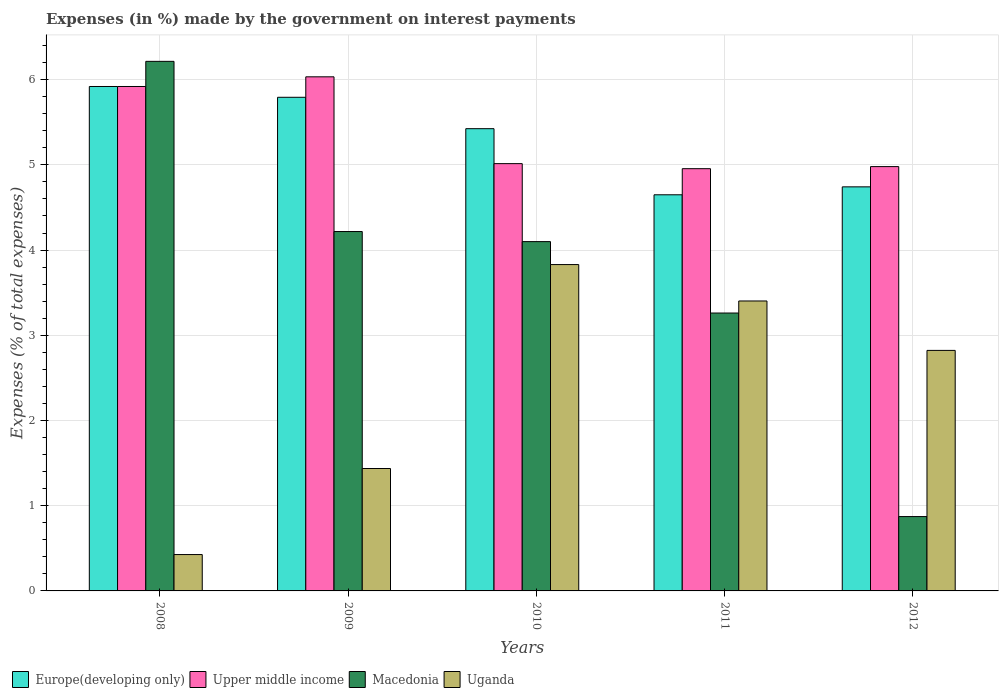How many different coloured bars are there?
Provide a short and direct response. 4. How many groups of bars are there?
Your answer should be compact. 5. Are the number of bars per tick equal to the number of legend labels?
Make the answer very short. Yes. Are the number of bars on each tick of the X-axis equal?
Make the answer very short. Yes. How many bars are there on the 3rd tick from the left?
Your answer should be compact. 4. How many bars are there on the 3rd tick from the right?
Keep it short and to the point. 4. What is the label of the 4th group of bars from the left?
Offer a terse response. 2011. What is the percentage of expenses made by the government on interest payments in Uganda in 2009?
Offer a very short reply. 1.44. Across all years, what is the maximum percentage of expenses made by the government on interest payments in Uganda?
Offer a very short reply. 3.83. Across all years, what is the minimum percentage of expenses made by the government on interest payments in Europe(developing only)?
Ensure brevity in your answer.  4.65. In which year was the percentage of expenses made by the government on interest payments in Europe(developing only) maximum?
Offer a terse response. 2008. In which year was the percentage of expenses made by the government on interest payments in Uganda minimum?
Your answer should be compact. 2008. What is the total percentage of expenses made by the government on interest payments in Macedonia in the graph?
Ensure brevity in your answer.  18.66. What is the difference between the percentage of expenses made by the government on interest payments in Upper middle income in 2010 and that in 2011?
Provide a succinct answer. 0.06. What is the difference between the percentage of expenses made by the government on interest payments in Upper middle income in 2008 and the percentage of expenses made by the government on interest payments in Uganda in 2009?
Your response must be concise. 4.48. What is the average percentage of expenses made by the government on interest payments in Uganda per year?
Keep it short and to the point. 2.38. In the year 2008, what is the difference between the percentage of expenses made by the government on interest payments in Macedonia and percentage of expenses made by the government on interest payments in Uganda?
Offer a terse response. 5.79. What is the ratio of the percentage of expenses made by the government on interest payments in Europe(developing only) in 2011 to that in 2012?
Provide a succinct answer. 0.98. Is the difference between the percentage of expenses made by the government on interest payments in Macedonia in 2010 and 2012 greater than the difference between the percentage of expenses made by the government on interest payments in Uganda in 2010 and 2012?
Your answer should be compact. Yes. What is the difference between the highest and the second highest percentage of expenses made by the government on interest payments in Europe(developing only)?
Make the answer very short. 0.13. What is the difference between the highest and the lowest percentage of expenses made by the government on interest payments in Europe(developing only)?
Provide a short and direct response. 1.27. What does the 4th bar from the left in 2011 represents?
Keep it short and to the point. Uganda. What does the 1st bar from the right in 2009 represents?
Provide a succinct answer. Uganda. Are all the bars in the graph horizontal?
Keep it short and to the point. No. What is the difference between two consecutive major ticks on the Y-axis?
Make the answer very short. 1. Are the values on the major ticks of Y-axis written in scientific E-notation?
Provide a succinct answer. No. Does the graph contain any zero values?
Provide a succinct answer. No. How many legend labels are there?
Ensure brevity in your answer.  4. What is the title of the graph?
Your answer should be compact. Expenses (in %) made by the government on interest payments. Does "Fragile and conflict affected situations" appear as one of the legend labels in the graph?
Your answer should be very brief. No. What is the label or title of the Y-axis?
Make the answer very short. Expenses (% of total expenses). What is the Expenses (% of total expenses) in Europe(developing only) in 2008?
Keep it short and to the point. 5.92. What is the Expenses (% of total expenses) of Upper middle income in 2008?
Provide a short and direct response. 5.92. What is the Expenses (% of total expenses) in Macedonia in 2008?
Offer a terse response. 6.21. What is the Expenses (% of total expenses) of Uganda in 2008?
Make the answer very short. 0.43. What is the Expenses (% of total expenses) of Europe(developing only) in 2009?
Give a very brief answer. 5.79. What is the Expenses (% of total expenses) in Upper middle income in 2009?
Provide a succinct answer. 6.03. What is the Expenses (% of total expenses) of Macedonia in 2009?
Provide a succinct answer. 4.22. What is the Expenses (% of total expenses) in Uganda in 2009?
Offer a very short reply. 1.44. What is the Expenses (% of total expenses) of Europe(developing only) in 2010?
Your answer should be compact. 5.42. What is the Expenses (% of total expenses) of Upper middle income in 2010?
Give a very brief answer. 5.01. What is the Expenses (% of total expenses) of Macedonia in 2010?
Provide a succinct answer. 4.1. What is the Expenses (% of total expenses) in Uganda in 2010?
Make the answer very short. 3.83. What is the Expenses (% of total expenses) in Europe(developing only) in 2011?
Your answer should be very brief. 4.65. What is the Expenses (% of total expenses) of Upper middle income in 2011?
Keep it short and to the point. 4.96. What is the Expenses (% of total expenses) in Macedonia in 2011?
Ensure brevity in your answer.  3.26. What is the Expenses (% of total expenses) of Uganda in 2011?
Keep it short and to the point. 3.4. What is the Expenses (% of total expenses) of Europe(developing only) in 2012?
Your answer should be compact. 4.74. What is the Expenses (% of total expenses) of Upper middle income in 2012?
Offer a very short reply. 4.98. What is the Expenses (% of total expenses) of Macedonia in 2012?
Provide a succinct answer. 0.87. What is the Expenses (% of total expenses) in Uganda in 2012?
Provide a succinct answer. 2.82. Across all years, what is the maximum Expenses (% of total expenses) in Europe(developing only)?
Your answer should be compact. 5.92. Across all years, what is the maximum Expenses (% of total expenses) of Upper middle income?
Your response must be concise. 6.03. Across all years, what is the maximum Expenses (% of total expenses) of Macedonia?
Provide a short and direct response. 6.21. Across all years, what is the maximum Expenses (% of total expenses) in Uganda?
Provide a short and direct response. 3.83. Across all years, what is the minimum Expenses (% of total expenses) in Europe(developing only)?
Offer a terse response. 4.65. Across all years, what is the minimum Expenses (% of total expenses) of Upper middle income?
Your response must be concise. 4.96. Across all years, what is the minimum Expenses (% of total expenses) in Macedonia?
Offer a terse response. 0.87. Across all years, what is the minimum Expenses (% of total expenses) in Uganda?
Offer a terse response. 0.43. What is the total Expenses (% of total expenses) in Europe(developing only) in the graph?
Offer a very short reply. 26.53. What is the total Expenses (% of total expenses) in Upper middle income in the graph?
Your answer should be compact. 26.9. What is the total Expenses (% of total expenses) in Macedonia in the graph?
Provide a short and direct response. 18.66. What is the total Expenses (% of total expenses) of Uganda in the graph?
Give a very brief answer. 11.92. What is the difference between the Expenses (% of total expenses) of Europe(developing only) in 2008 and that in 2009?
Give a very brief answer. 0.13. What is the difference between the Expenses (% of total expenses) of Upper middle income in 2008 and that in 2009?
Offer a very short reply. -0.11. What is the difference between the Expenses (% of total expenses) in Macedonia in 2008 and that in 2009?
Provide a succinct answer. 2. What is the difference between the Expenses (% of total expenses) in Uganda in 2008 and that in 2009?
Your answer should be compact. -1.01. What is the difference between the Expenses (% of total expenses) of Europe(developing only) in 2008 and that in 2010?
Give a very brief answer. 0.5. What is the difference between the Expenses (% of total expenses) of Upper middle income in 2008 and that in 2010?
Keep it short and to the point. 0.91. What is the difference between the Expenses (% of total expenses) of Macedonia in 2008 and that in 2010?
Make the answer very short. 2.12. What is the difference between the Expenses (% of total expenses) in Uganda in 2008 and that in 2010?
Your answer should be very brief. -3.4. What is the difference between the Expenses (% of total expenses) of Europe(developing only) in 2008 and that in 2011?
Ensure brevity in your answer.  1.27. What is the difference between the Expenses (% of total expenses) in Upper middle income in 2008 and that in 2011?
Your answer should be very brief. 0.96. What is the difference between the Expenses (% of total expenses) in Macedonia in 2008 and that in 2011?
Offer a very short reply. 2.95. What is the difference between the Expenses (% of total expenses) of Uganda in 2008 and that in 2011?
Make the answer very short. -2.98. What is the difference between the Expenses (% of total expenses) of Europe(developing only) in 2008 and that in 2012?
Your response must be concise. 1.18. What is the difference between the Expenses (% of total expenses) in Upper middle income in 2008 and that in 2012?
Ensure brevity in your answer.  0.94. What is the difference between the Expenses (% of total expenses) in Macedonia in 2008 and that in 2012?
Offer a terse response. 5.34. What is the difference between the Expenses (% of total expenses) of Uganda in 2008 and that in 2012?
Offer a terse response. -2.4. What is the difference between the Expenses (% of total expenses) in Europe(developing only) in 2009 and that in 2010?
Your answer should be compact. 0.37. What is the difference between the Expenses (% of total expenses) of Upper middle income in 2009 and that in 2010?
Keep it short and to the point. 1.02. What is the difference between the Expenses (% of total expenses) of Macedonia in 2009 and that in 2010?
Make the answer very short. 0.12. What is the difference between the Expenses (% of total expenses) of Uganda in 2009 and that in 2010?
Keep it short and to the point. -2.39. What is the difference between the Expenses (% of total expenses) of Europe(developing only) in 2009 and that in 2011?
Your answer should be very brief. 1.14. What is the difference between the Expenses (% of total expenses) in Upper middle income in 2009 and that in 2011?
Make the answer very short. 1.08. What is the difference between the Expenses (% of total expenses) of Macedonia in 2009 and that in 2011?
Provide a short and direct response. 0.96. What is the difference between the Expenses (% of total expenses) of Uganda in 2009 and that in 2011?
Ensure brevity in your answer.  -1.97. What is the difference between the Expenses (% of total expenses) in Europe(developing only) in 2009 and that in 2012?
Give a very brief answer. 1.05. What is the difference between the Expenses (% of total expenses) in Upper middle income in 2009 and that in 2012?
Provide a succinct answer. 1.05. What is the difference between the Expenses (% of total expenses) of Macedonia in 2009 and that in 2012?
Your answer should be compact. 3.34. What is the difference between the Expenses (% of total expenses) of Uganda in 2009 and that in 2012?
Provide a succinct answer. -1.39. What is the difference between the Expenses (% of total expenses) in Europe(developing only) in 2010 and that in 2011?
Your answer should be very brief. 0.78. What is the difference between the Expenses (% of total expenses) in Upper middle income in 2010 and that in 2011?
Provide a succinct answer. 0.06. What is the difference between the Expenses (% of total expenses) of Macedonia in 2010 and that in 2011?
Provide a succinct answer. 0.84. What is the difference between the Expenses (% of total expenses) of Uganda in 2010 and that in 2011?
Provide a succinct answer. 0.43. What is the difference between the Expenses (% of total expenses) in Europe(developing only) in 2010 and that in 2012?
Your answer should be very brief. 0.68. What is the difference between the Expenses (% of total expenses) in Upper middle income in 2010 and that in 2012?
Offer a terse response. 0.03. What is the difference between the Expenses (% of total expenses) in Macedonia in 2010 and that in 2012?
Keep it short and to the point. 3.23. What is the difference between the Expenses (% of total expenses) of Uganda in 2010 and that in 2012?
Provide a succinct answer. 1.01. What is the difference between the Expenses (% of total expenses) in Europe(developing only) in 2011 and that in 2012?
Make the answer very short. -0.09. What is the difference between the Expenses (% of total expenses) in Upper middle income in 2011 and that in 2012?
Provide a succinct answer. -0.02. What is the difference between the Expenses (% of total expenses) in Macedonia in 2011 and that in 2012?
Your answer should be compact. 2.39. What is the difference between the Expenses (% of total expenses) of Uganda in 2011 and that in 2012?
Give a very brief answer. 0.58. What is the difference between the Expenses (% of total expenses) of Europe(developing only) in 2008 and the Expenses (% of total expenses) of Upper middle income in 2009?
Your answer should be very brief. -0.11. What is the difference between the Expenses (% of total expenses) of Europe(developing only) in 2008 and the Expenses (% of total expenses) of Macedonia in 2009?
Your answer should be compact. 1.7. What is the difference between the Expenses (% of total expenses) of Europe(developing only) in 2008 and the Expenses (% of total expenses) of Uganda in 2009?
Provide a succinct answer. 4.48. What is the difference between the Expenses (% of total expenses) in Upper middle income in 2008 and the Expenses (% of total expenses) in Macedonia in 2009?
Ensure brevity in your answer.  1.7. What is the difference between the Expenses (% of total expenses) in Upper middle income in 2008 and the Expenses (% of total expenses) in Uganda in 2009?
Provide a succinct answer. 4.48. What is the difference between the Expenses (% of total expenses) of Macedonia in 2008 and the Expenses (% of total expenses) of Uganda in 2009?
Give a very brief answer. 4.78. What is the difference between the Expenses (% of total expenses) of Europe(developing only) in 2008 and the Expenses (% of total expenses) of Upper middle income in 2010?
Your answer should be very brief. 0.91. What is the difference between the Expenses (% of total expenses) in Europe(developing only) in 2008 and the Expenses (% of total expenses) in Macedonia in 2010?
Your answer should be compact. 1.82. What is the difference between the Expenses (% of total expenses) of Europe(developing only) in 2008 and the Expenses (% of total expenses) of Uganda in 2010?
Make the answer very short. 2.09. What is the difference between the Expenses (% of total expenses) in Upper middle income in 2008 and the Expenses (% of total expenses) in Macedonia in 2010?
Provide a succinct answer. 1.82. What is the difference between the Expenses (% of total expenses) in Upper middle income in 2008 and the Expenses (% of total expenses) in Uganda in 2010?
Make the answer very short. 2.09. What is the difference between the Expenses (% of total expenses) of Macedonia in 2008 and the Expenses (% of total expenses) of Uganda in 2010?
Offer a very short reply. 2.38. What is the difference between the Expenses (% of total expenses) of Europe(developing only) in 2008 and the Expenses (% of total expenses) of Upper middle income in 2011?
Your answer should be very brief. 0.96. What is the difference between the Expenses (% of total expenses) in Europe(developing only) in 2008 and the Expenses (% of total expenses) in Macedonia in 2011?
Make the answer very short. 2.66. What is the difference between the Expenses (% of total expenses) of Europe(developing only) in 2008 and the Expenses (% of total expenses) of Uganda in 2011?
Offer a terse response. 2.52. What is the difference between the Expenses (% of total expenses) in Upper middle income in 2008 and the Expenses (% of total expenses) in Macedonia in 2011?
Give a very brief answer. 2.66. What is the difference between the Expenses (% of total expenses) in Upper middle income in 2008 and the Expenses (% of total expenses) in Uganda in 2011?
Your answer should be very brief. 2.52. What is the difference between the Expenses (% of total expenses) of Macedonia in 2008 and the Expenses (% of total expenses) of Uganda in 2011?
Your answer should be very brief. 2.81. What is the difference between the Expenses (% of total expenses) of Europe(developing only) in 2008 and the Expenses (% of total expenses) of Upper middle income in 2012?
Provide a short and direct response. 0.94. What is the difference between the Expenses (% of total expenses) of Europe(developing only) in 2008 and the Expenses (% of total expenses) of Macedonia in 2012?
Provide a succinct answer. 5.05. What is the difference between the Expenses (% of total expenses) of Europe(developing only) in 2008 and the Expenses (% of total expenses) of Uganda in 2012?
Your answer should be very brief. 3.1. What is the difference between the Expenses (% of total expenses) of Upper middle income in 2008 and the Expenses (% of total expenses) of Macedonia in 2012?
Provide a succinct answer. 5.05. What is the difference between the Expenses (% of total expenses) of Upper middle income in 2008 and the Expenses (% of total expenses) of Uganda in 2012?
Ensure brevity in your answer.  3.1. What is the difference between the Expenses (% of total expenses) in Macedonia in 2008 and the Expenses (% of total expenses) in Uganda in 2012?
Offer a very short reply. 3.39. What is the difference between the Expenses (% of total expenses) of Europe(developing only) in 2009 and the Expenses (% of total expenses) of Upper middle income in 2010?
Your response must be concise. 0.78. What is the difference between the Expenses (% of total expenses) of Europe(developing only) in 2009 and the Expenses (% of total expenses) of Macedonia in 2010?
Your response must be concise. 1.69. What is the difference between the Expenses (% of total expenses) in Europe(developing only) in 2009 and the Expenses (% of total expenses) in Uganda in 2010?
Your answer should be compact. 1.96. What is the difference between the Expenses (% of total expenses) of Upper middle income in 2009 and the Expenses (% of total expenses) of Macedonia in 2010?
Ensure brevity in your answer.  1.93. What is the difference between the Expenses (% of total expenses) in Upper middle income in 2009 and the Expenses (% of total expenses) in Uganda in 2010?
Give a very brief answer. 2.2. What is the difference between the Expenses (% of total expenses) of Macedonia in 2009 and the Expenses (% of total expenses) of Uganda in 2010?
Offer a terse response. 0.39. What is the difference between the Expenses (% of total expenses) in Europe(developing only) in 2009 and the Expenses (% of total expenses) in Upper middle income in 2011?
Give a very brief answer. 0.84. What is the difference between the Expenses (% of total expenses) of Europe(developing only) in 2009 and the Expenses (% of total expenses) of Macedonia in 2011?
Offer a very short reply. 2.53. What is the difference between the Expenses (% of total expenses) in Europe(developing only) in 2009 and the Expenses (% of total expenses) in Uganda in 2011?
Offer a terse response. 2.39. What is the difference between the Expenses (% of total expenses) in Upper middle income in 2009 and the Expenses (% of total expenses) in Macedonia in 2011?
Your response must be concise. 2.77. What is the difference between the Expenses (% of total expenses) of Upper middle income in 2009 and the Expenses (% of total expenses) of Uganda in 2011?
Give a very brief answer. 2.63. What is the difference between the Expenses (% of total expenses) in Macedonia in 2009 and the Expenses (% of total expenses) in Uganda in 2011?
Your answer should be compact. 0.81. What is the difference between the Expenses (% of total expenses) of Europe(developing only) in 2009 and the Expenses (% of total expenses) of Upper middle income in 2012?
Provide a short and direct response. 0.81. What is the difference between the Expenses (% of total expenses) of Europe(developing only) in 2009 and the Expenses (% of total expenses) of Macedonia in 2012?
Offer a very short reply. 4.92. What is the difference between the Expenses (% of total expenses) of Europe(developing only) in 2009 and the Expenses (% of total expenses) of Uganda in 2012?
Your answer should be very brief. 2.97. What is the difference between the Expenses (% of total expenses) in Upper middle income in 2009 and the Expenses (% of total expenses) in Macedonia in 2012?
Provide a succinct answer. 5.16. What is the difference between the Expenses (% of total expenses) in Upper middle income in 2009 and the Expenses (% of total expenses) in Uganda in 2012?
Make the answer very short. 3.21. What is the difference between the Expenses (% of total expenses) of Macedonia in 2009 and the Expenses (% of total expenses) of Uganda in 2012?
Your answer should be compact. 1.39. What is the difference between the Expenses (% of total expenses) in Europe(developing only) in 2010 and the Expenses (% of total expenses) in Upper middle income in 2011?
Provide a short and direct response. 0.47. What is the difference between the Expenses (% of total expenses) in Europe(developing only) in 2010 and the Expenses (% of total expenses) in Macedonia in 2011?
Provide a succinct answer. 2.16. What is the difference between the Expenses (% of total expenses) of Europe(developing only) in 2010 and the Expenses (% of total expenses) of Uganda in 2011?
Offer a terse response. 2.02. What is the difference between the Expenses (% of total expenses) in Upper middle income in 2010 and the Expenses (% of total expenses) in Macedonia in 2011?
Offer a terse response. 1.75. What is the difference between the Expenses (% of total expenses) of Upper middle income in 2010 and the Expenses (% of total expenses) of Uganda in 2011?
Provide a short and direct response. 1.61. What is the difference between the Expenses (% of total expenses) of Macedonia in 2010 and the Expenses (% of total expenses) of Uganda in 2011?
Ensure brevity in your answer.  0.7. What is the difference between the Expenses (% of total expenses) of Europe(developing only) in 2010 and the Expenses (% of total expenses) of Upper middle income in 2012?
Keep it short and to the point. 0.45. What is the difference between the Expenses (% of total expenses) of Europe(developing only) in 2010 and the Expenses (% of total expenses) of Macedonia in 2012?
Offer a terse response. 4.55. What is the difference between the Expenses (% of total expenses) in Europe(developing only) in 2010 and the Expenses (% of total expenses) in Uganda in 2012?
Provide a succinct answer. 2.6. What is the difference between the Expenses (% of total expenses) in Upper middle income in 2010 and the Expenses (% of total expenses) in Macedonia in 2012?
Give a very brief answer. 4.14. What is the difference between the Expenses (% of total expenses) of Upper middle income in 2010 and the Expenses (% of total expenses) of Uganda in 2012?
Provide a succinct answer. 2.19. What is the difference between the Expenses (% of total expenses) in Macedonia in 2010 and the Expenses (% of total expenses) in Uganda in 2012?
Provide a short and direct response. 1.28. What is the difference between the Expenses (% of total expenses) in Europe(developing only) in 2011 and the Expenses (% of total expenses) in Upper middle income in 2012?
Your answer should be very brief. -0.33. What is the difference between the Expenses (% of total expenses) in Europe(developing only) in 2011 and the Expenses (% of total expenses) in Macedonia in 2012?
Offer a terse response. 3.78. What is the difference between the Expenses (% of total expenses) of Europe(developing only) in 2011 and the Expenses (% of total expenses) of Uganda in 2012?
Offer a very short reply. 1.83. What is the difference between the Expenses (% of total expenses) of Upper middle income in 2011 and the Expenses (% of total expenses) of Macedonia in 2012?
Ensure brevity in your answer.  4.08. What is the difference between the Expenses (% of total expenses) in Upper middle income in 2011 and the Expenses (% of total expenses) in Uganda in 2012?
Keep it short and to the point. 2.13. What is the difference between the Expenses (% of total expenses) in Macedonia in 2011 and the Expenses (% of total expenses) in Uganda in 2012?
Offer a terse response. 0.44. What is the average Expenses (% of total expenses) of Europe(developing only) per year?
Offer a very short reply. 5.31. What is the average Expenses (% of total expenses) of Upper middle income per year?
Provide a succinct answer. 5.38. What is the average Expenses (% of total expenses) of Macedonia per year?
Offer a terse response. 3.73. What is the average Expenses (% of total expenses) in Uganda per year?
Make the answer very short. 2.38. In the year 2008, what is the difference between the Expenses (% of total expenses) in Europe(developing only) and Expenses (% of total expenses) in Macedonia?
Keep it short and to the point. -0.29. In the year 2008, what is the difference between the Expenses (% of total expenses) in Europe(developing only) and Expenses (% of total expenses) in Uganda?
Provide a short and direct response. 5.49. In the year 2008, what is the difference between the Expenses (% of total expenses) of Upper middle income and Expenses (% of total expenses) of Macedonia?
Provide a succinct answer. -0.29. In the year 2008, what is the difference between the Expenses (% of total expenses) in Upper middle income and Expenses (% of total expenses) in Uganda?
Make the answer very short. 5.49. In the year 2008, what is the difference between the Expenses (% of total expenses) in Macedonia and Expenses (% of total expenses) in Uganda?
Keep it short and to the point. 5.79. In the year 2009, what is the difference between the Expenses (% of total expenses) of Europe(developing only) and Expenses (% of total expenses) of Upper middle income?
Ensure brevity in your answer.  -0.24. In the year 2009, what is the difference between the Expenses (% of total expenses) in Europe(developing only) and Expenses (% of total expenses) in Macedonia?
Keep it short and to the point. 1.58. In the year 2009, what is the difference between the Expenses (% of total expenses) in Europe(developing only) and Expenses (% of total expenses) in Uganda?
Keep it short and to the point. 4.36. In the year 2009, what is the difference between the Expenses (% of total expenses) of Upper middle income and Expenses (% of total expenses) of Macedonia?
Offer a terse response. 1.82. In the year 2009, what is the difference between the Expenses (% of total expenses) in Upper middle income and Expenses (% of total expenses) in Uganda?
Give a very brief answer. 4.6. In the year 2009, what is the difference between the Expenses (% of total expenses) in Macedonia and Expenses (% of total expenses) in Uganda?
Offer a very short reply. 2.78. In the year 2010, what is the difference between the Expenses (% of total expenses) in Europe(developing only) and Expenses (% of total expenses) in Upper middle income?
Make the answer very short. 0.41. In the year 2010, what is the difference between the Expenses (% of total expenses) in Europe(developing only) and Expenses (% of total expenses) in Macedonia?
Your answer should be compact. 1.33. In the year 2010, what is the difference between the Expenses (% of total expenses) of Europe(developing only) and Expenses (% of total expenses) of Uganda?
Keep it short and to the point. 1.59. In the year 2010, what is the difference between the Expenses (% of total expenses) in Upper middle income and Expenses (% of total expenses) in Macedonia?
Offer a very short reply. 0.92. In the year 2010, what is the difference between the Expenses (% of total expenses) of Upper middle income and Expenses (% of total expenses) of Uganda?
Offer a very short reply. 1.18. In the year 2010, what is the difference between the Expenses (% of total expenses) in Macedonia and Expenses (% of total expenses) in Uganda?
Provide a short and direct response. 0.27. In the year 2011, what is the difference between the Expenses (% of total expenses) in Europe(developing only) and Expenses (% of total expenses) in Upper middle income?
Give a very brief answer. -0.31. In the year 2011, what is the difference between the Expenses (% of total expenses) of Europe(developing only) and Expenses (% of total expenses) of Macedonia?
Your response must be concise. 1.39. In the year 2011, what is the difference between the Expenses (% of total expenses) in Europe(developing only) and Expenses (% of total expenses) in Uganda?
Provide a succinct answer. 1.25. In the year 2011, what is the difference between the Expenses (% of total expenses) in Upper middle income and Expenses (% of total expenses) in Macedonia?
Ensure brevity in your answer.  1.69. In the year 2011, what is the difference between the Expenses (% of total expenses) in Upper middle income and Expenses (% of total expenses) in Uganda?
Offer a very short reply. 1.55. In the year 2011, what is the difference between the Expenses (% of total expenses) in Macedonia and Expenses (% of total expenses) in Uganda?
Give a very brief answer. -0.14. In the year 2012, what is the difference between the Expenses (% of total expenses) in Europe(developing only) and Expenses (% of total expenses) in Upper middle income?
Your answer should be compact. -0.24. In the year 2012, what is the difference between the Expenses (% of total expenses) of Europe(developing only) and Expenses (% of total expenses) of Macedonia?
Your answer should be very brief. 3.87. In the year 2012, what is the difference between the Expenses (% of total expenses) in Europe(developing only) and Expenses (% of total expenses) in Uganda?
Provide a short and direct response. 1.92. In the year 2012, what is the difference between the Expenses (% of total expenses) of Upper middle income and Expenses (% of total expenses) of Macedonia?
Make the answer very short. 4.11. In the year 2012, what is the difference between the Expenses (% of total expenses) in Upper middle income and Expenses (% of total expenses) in Uganda?
Give a very brief answer. 2.16. In the year 2012, what is the difference between the Expenses (% of total expenses) of Macedonia and Expenses (% of total expenses) of Uganda?
Make the answer very short. -1.95. What is the ratio of the Expenses (% of total expenses) in Europe(developing only) in 2008 to that in 2009?
Your answer should be compact. 1.02. What is the ratio of the Expenses (% of total expenses) in Upper middle income in 2008 to that in 2009?
Your response must be concise. 0.98. What is the ratio of the Expenses (% of total expenses) in Macedonia in 2008 to that in 2009?
Your answer should be compact. 1.47. What is the ratio of the Expenses (% of total expenses) in Uganda in 2008 to that in 2009?
Make the answer very short. 0.3. What is the ratio of the Expenses (% of total expenses) of Europe(developing only) in 2008 to that in 2010?
Ensure brevity in your answer.  1.09. What is the ratio of the Expenses (% of total expenses) in Upper middle income in 2008 to that in 2010?
Give a very brief answer. 1.18. What is the ratio of the Expenses (% of total expenses) in Macedonia in 2008 to that in 2010?
Offer a terse response. 1.52. What is the ratio of the Expenses (% of total expenses) in Uganda in 2008 to that in 2010?
Provide a short and direct response. 0.11. What is the ratio of the Expenses (% of total expenses) of Europe(developing only) in 2008 to that in 2011?
Make the answer very short. 1.27. What is the ratio of the Expenses (% of total expenses) of Upper middle income in 2008 to that in 2011?
Offer a terse response. 1.19. What is the ratio of the Expenses (% of total expenses) of Macedonia in 2008 to that in 2011?
Provide a short and direct response. 1.91. What is the ratio of the Expenses (% of total expenses) in Uganda in 2008 to that in 2011?
Your answer should be very brief. 0.13. What is the ratio of the Expenses (% of total expenses) in Europe(developing only) in 2008 to that in 2012?
Provide a succinct answer. 1.25. What is the ratio of the Expenses (% of total expenses) of Upper middle income in 2008 to that in 2012?
Offer a very short reply. 1.19. What is the ratio of the Expenses (% of total expenses) in Macedonia in 2008 to that in 2012?
Offer a terse response. 7.12. What is the ratio of the Expenses (% of total expenses) in Uganda in 2008 to that in 2012?
Provide a succinct answer. 0.15. What is the ratio of the Expenses (% of total expenses) of Europe(developing only) in 2009 to that in 2010?
Your answer should be compact. 1.07. What is the ratio of the Expenses (% of total expenses) of Upper middle income in 2009 to that in 2010?
Provide a short and direct response. 1.2. What is the ratio of the Expenses (% of total expenses) in Macedonia in 2009 to that in 2010?
Make the answer very short. 1.03. What is the ratio of the Expenses (% of total expenses) of Uganda in 2009 to that in 2010?
Your answer should be compact. 0.38. What is the ratio of the Expenses (% of total expenses) in Europe(developing only) in 2009 to that in 2011?
Your answer should be compact. 1.25. What is the ratio of the Expenses (% of total expenses) in Upper middle income in 2009 to that in 2011?
Ensure brevity in your answer.  1.22. What is the ratio of the Expenses (% of total expenses) of Macedonia in 2009 to that in 2011?
Your answer should be very brief. 1.29. What is the ratio of the Expenses (% of total expenses) in Uganda in 2009 to that in 2011?
Provide a succinct answer. 0.42. What is the ratio of the Expenses (% of total expenses) in Europe(developing only) in 2009 to that in 2012?
Keep it short and to the point. 1.22. What is the ratio of the Expenses (% of total expenses) of Upper middle income in 2009 to that in 2012?
Offer a very short reply. 1.21. What is the ratio of the Expenses (% of total expenses) of Macedonia in 2009 to that in 2012?
Make the answer very short. 4.83. What is the ratio of the Expenses (% of total expenses) in Uganda in 2009 to that in 2012?
Offer a very short reply. 0.51. What is the ratio of the Expenses (% of total expenses) in Europe(developing only) in 2010 to that in 2011?
Provide a succinct answer. 1.17. What is the ratio of the Expenses (% of total expenses) in Upper middle income in 2010 to that in 2011?
Provide a succinct answer. 1.01. What is the ratio of the Expenses (% of total expenses) in Macedonia in 2010 to that in 2011?
Give a very brief answer. 1.26. What is the ratio of the Expenses (% of total expenses) of Uganda in 2010 to that in 2011?
Your response must be concise. 1.13. What is the ratio of the Expenses (% of total expenses) in Europe(developing only) in 2010 to that in 2012?
Your response must be concise. 1.14. What is the ratio of the Expenses (% of total expenses) in Macedonia in 2010 to that in 2012?
Give a very brief answer. 4.7. What is the ratio of the Expenses (% of total expenses) of Uganda in 2010 to that in 2012?
Your answer should be compact. 1.36. What is the ratio of the Expenses (% of total expenses) of Europe(developing only) in 2011 to that in 2012?
Your answer should be very brief. 0.98. What is the ratio of the Expenses (% of total expenses) of Macedonia in 2011 to that in 2012?
Provide a succinct answer. 3.74. What is the ratio of the Expenses (% of total expenses) in Uganda in 2011 to that in 2012?
Offer a terse response. 1.21. What is the difference between the highest and the second highest Expenses (% of total expenses) of Europe(developing only)?
Offer a very short reply. 0.13. What is the difference between the highest and the second highest Expenses (% of total expenses) in Upper middle income?
Your answer should be very brief. 0.11. What is the difference between the highest and the second highest Expenses (% of total expenses) in Macedonia?
Give a very brief answer. 2. What is the difference between the highest and the second highest Expenses (% of total expenses) in Uganda?
Your answer should be very brief. 0.43. What is the difference between the highest and the lowest Expenses (% of total expenses) in Europe(developing only)?
Ensure brevity in your answer.  1.27. What is the difference between the highest and the lowest Expenses (% of total expenses) of Upper middle income?
Ensure brevity in your answer.  1.08. What is the difference between the highest and the lowest Expenses (% of total expenses) of Macedonia?
Offer a very short reply. 5.34. What is the difference between the highest and the lowest Expenses (% of total expenses) in Uganda?
Provide a succinct answer. 3.4. 